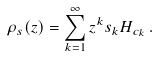Convert formula to latex. <formula><loc_0><loc_0><loc_500><loc_500>\rho _ { s } ( z ) = \sum _ { k = 1 } ^ { \infty } z ^ { k } s _ { k } H _ { c _ { k } } \, .</formula> 